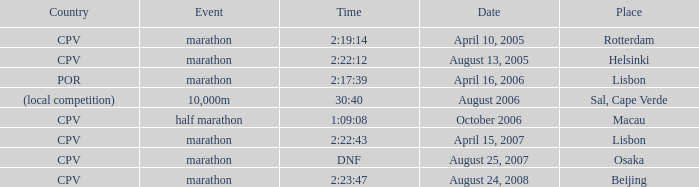Help me parse the entirety of this table. {'header': ['Country', 'Event', 'Time', 'Date', 'Place'], 'rows': [['CPV', 'marathon', '2:19:14', 'April 10, 2005', 'Rotterdam'], ['CPV', 'marathon', '2:22:12', 'August 13, 2005', 'Helsinki'], ['POR', 'marathon', '2:17:39', 'April 16, 2006', 'Lisbon'], ['(local competition)', '10,000m', '30:40', 'August 2006', 'Sal, Cape Verde'], ['CPV', 'half marathon', '1:09:08', 'October 2006', 'Macau'], ['CPV', 'marathon', '2:22:43', 'April 15, 2007', 'Lisbon'], ['CPV', 'marathon', 'DNF', 'August 25, 2007', 'Osaka'], ['CPV', 'marathon', '2:23:47', 'August 24, 2008', 'Beijing']]} What is the Event labeled Country of (local competition)? 10,000m. 